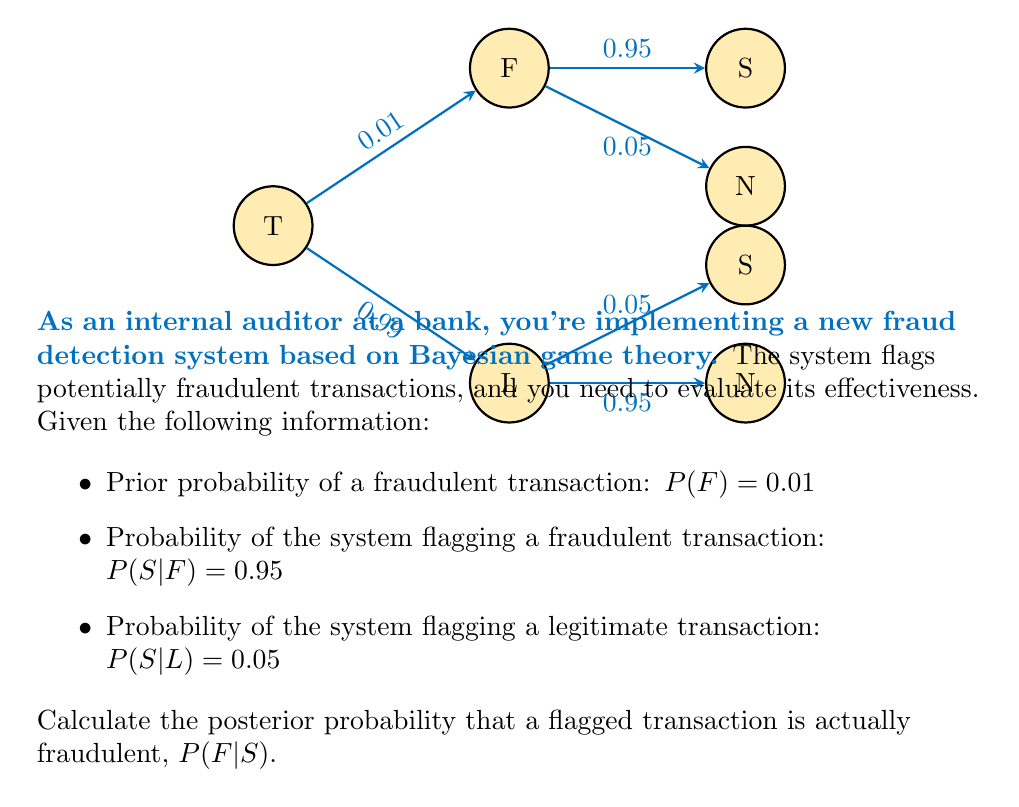Show me your answer to this math problem. Let's approach this step-by-step using Bayes' theorem:

1) Bayes' theorem states:

   $$P(F|S) = \frac{P(S|F) \cdot P(F)}{P(S)}$$

2) We're given $P(S|F)$, $P(F)$, but we need to calculate $P(S)$.

3) We can calculate $P(S)$ using the law of total probability:

   $$P(S) = P(S|F) \cdot P(F) + P(S|L) \cdot P(L)$$

4) We know $P(L) = 1 - P(F) = 0.99$, so:

   $$P(S) = 0.95 \cdot 0.01 + 0.05 \cdot 0.99 = 0.0095 + 0.0495 = 0.059$$

5) Now we can apply Bayes' theorem:

   $$P(F|S) = \frac{0.95 \cdot 0.01}{0.059} \approx 0.1610$$

6) Therefore, the posterior probability that a flagged transaction is actually fraudulent is approximately 0.1610 or 16.10%.

This result shows that while the system is good at catching fraudulent transactions (95% detection rate), the low base rate of fraud means that most flagged transactions will still be false positives. This highlights the importance of considering base rates in fraud detection.
Answer: $P(F|S) \approx 0.1610$ or 16.10% 